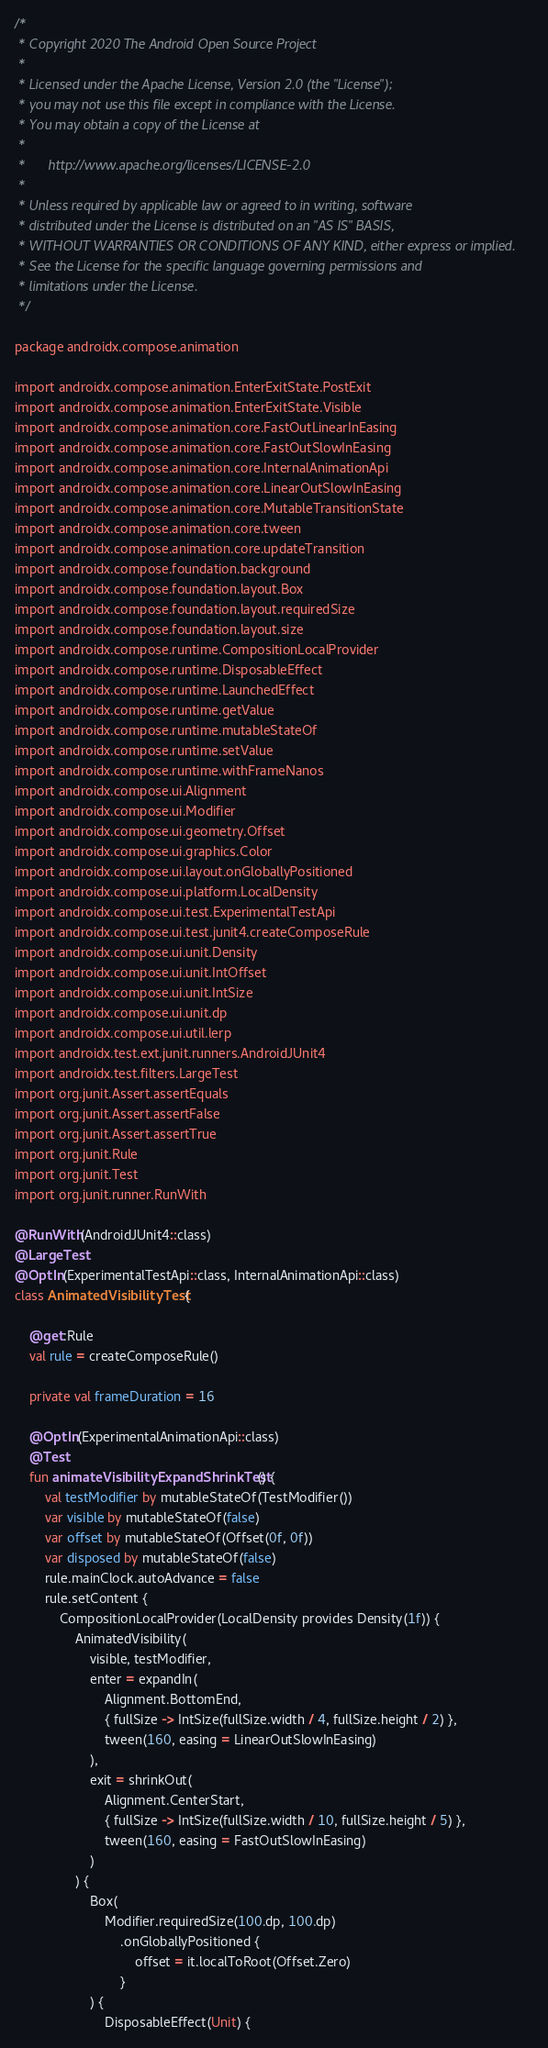Convert code to text. <code><loc_0><loc_0><loc_500><loc_500><_Kotlin_>/*
 * Copyright 2020 The Android Open Source Project
 *
 * Licensed under the Apache License, Version 2.0 (the "License");
 * you may not use this file except in compliance with the License.
 * You may obtain a copy of the License at
 *
 *      http://www.apache.org/licenses/LICENSE-2.0
 *
 * Unless required by applicable law or agreed to in writing, software
 * distributed under the License is distributed on an "AS IS" BASIS,
 * WITHOUT WARRANTIES OR CONDITIONS OF ANY KIND, either express or implied.
 * See the License for the specific language governing permissions and
 * limitations under the License.
 */

package androidx.compose.animation

import androidx.compose.animation.EnterExitState.PostExit
import androidx.compose.animation.EnterExitState.Visible
import androidx.compose.animation.core.FastOutLinearInEasing
import androidx.compose.animation.core.FastOutSlowInEasing
import androidx.compose.animation.core.InternalAnimationApi
import androidx.compose.animation.core.LinearOutSlowInEasing
import androidx.compose.animation.core.MutableTransitionState
import androidx.compose.animation.core.tween
import androidx.compose.animation.core.updateTransition
import androidx.compose.foundation.background
import androidx.compose.foundation.layout.Box
import androidx.compose.foundation.layout.requiredSize
import androidx.compose.foundation.layout.size
import androidx.compose.runtime.CompositionLocalProvider
import androidx.compose.runtime.DisposableEffect
import androidx.compose.runtime.LaunchedEffect
import androidx.compose.runtime.getValue
import androidx.compose.runtime.mutableStateOf
import androidx.compose.runtime.setValue
import androidx.compose.runtime.withFrameNanos
import androidx.compose.ui.Alignment
import androidx.compose.ui.Modifier
import androidx.compose.ui.geometry.Offset
import androidx.compose.ui.graphics.Color
import androidx.compose.ui.layout.onGloballyPositioned
import androidx.compose.ui.platform.LocalDensity
import androidx.compose.ui.test.ExperimentalTestApi
import androidx.compose.ui.test.junit4.createComposeRule
import androidx.compose.ui.unit.Density
import androidx.compose.ui.unit.IntOffset
import androidx.compose.ui.unit.IntSize
import androidx.compose.ui.unit.dp
import androidx.compose.ui.util.lerp
import androidx.test.ext.junit.runners.AndroidJUnit4
import androidx.test.filters.LargeTest
import org.junit.Assert.assertEquals
import org.junit.Assert.assertFalse
import org.junit.Assert.assertTrue
import org.junit.Rule
import org.junit.Test
import org.junit.runner.RunWith

@RunWith(AndroidJUnit4::class)
@LargeTest
@OptIn(ExperimentalTestApi::class, InternalAnimationApi::class)
class AnimatedVisibilityTest {

    @get:Rule
    val rule = createComposeRule()

    private val frameDuration = 16

    @OptIn(ExperimentalAnimationApi::class)
    @Test
    fun animateVisibilityExpandShrinkTest() {
        val testModifier by mutableStateOf(TestModifier())
        var visible by mutableStateOf(false)
        var offset by mutableStateOf(Offset(0f, 0f))
        var disposed by mutableStateOf(false)
        rule.mainClock.autoAdvance = false
        rule.setContent {
            CompositionLocalProvider(LocalDensity provides Density(1f)) {
                AnimatedVisibility(
                    visible, testModifier,
                    enter = expandIn(
                        Alignment.BottomEnd,
                        { fullSize -> IntSize(fullSize.width / 4, fullSize.height / 2) },
                        tween(160, easing = LinearOutSlowInEasing)
                    ),
                    exit = shrinkOut(
                        Alignment.CenterStart,
                        { fullSize -> IntSize(fullSize.width / 10, fullSize.height / 5) },
                        tween(160, easing = FastOutSlowInEasing)
                    )
                ) {
                    Box(
                        Modifier.requiredSize(100.dp, 100.dp)
                            .onGloballyPositioned {
                                offset = it.localToRoot(Offset.Zero)
                            }
                    ) {
                        DisposableEffect(Unit) {</code> 